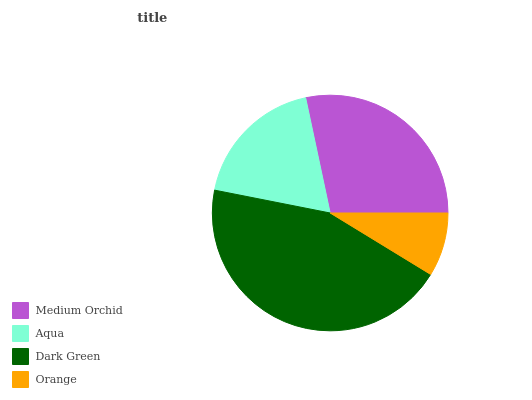Is Orange the minimum?
Answer yes or no. Yes. Is Dark Green the maximum?
Answer yes or no. Yes. Is Aqua the minimum?
Answer yes or no. No. Is Aqua the maximum?
Answer yes or no. No. Is Medium Orchid greater than Aqua?
Answer yes or no. Yes. Is Aqua less than Medium Orchid?
Answer yes or no. Yes. Is Aqua greater than Medium Orchid?
Answer yes or no. No. Is Medium Orchid less than Aqua?
Answer yes or no. No. Is Medium Orchid the high median?
Answer yes or no. Yes. Is Aqua the low median?
Answer yes or no. Yes. Is Aqua the high median?
Answer yes or no. No. Is Orange the low median?
Answer yes or no. No. 